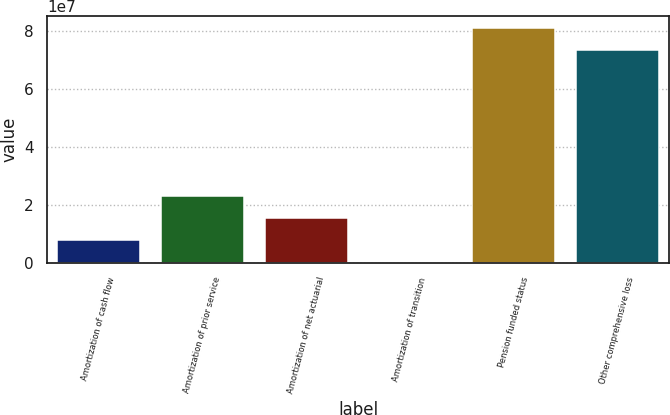Convert chart to OTSL. <chart><loc_0><loc_0><loc_500><loc_500><bar_chart><fcel>Amortization of cash flow<fcel>Amortization of prior service<fcel>Amortization of net actuarial<fcel>Amortization of transition<fcel>Pension funded status<fcel>Other comprehensive loss<nl><fcel>7.8027e+06<fcel>2.32881e+07<fcel>1.55454e+07<fcel>60000<fcel>8.13027e+07<fcel>7.356e+07<nl></chart> 